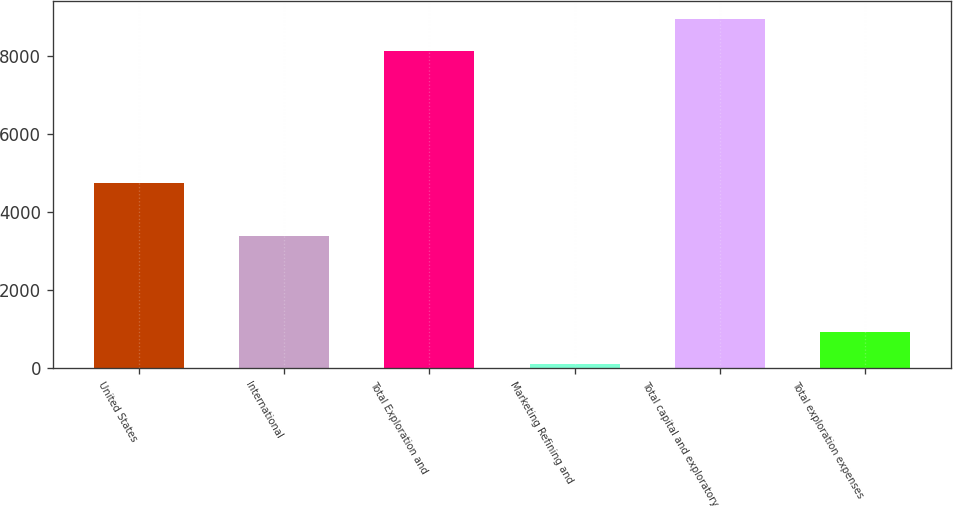Convert chart to OTSL. <chart><loc_0><loc_0><loc_500><loc_500><bar_chart><fcel>United States<fcel>International<fcel>Total Exploration and<fcel>Marketing Refining and<fcel>Total capital and exploratory<fcel>Total exploration expenses<nl><fcel>4763<fcel>3383<fcel>8146<fcel>119<fcel>8960.6<fcel>933.6<nl></chart> 